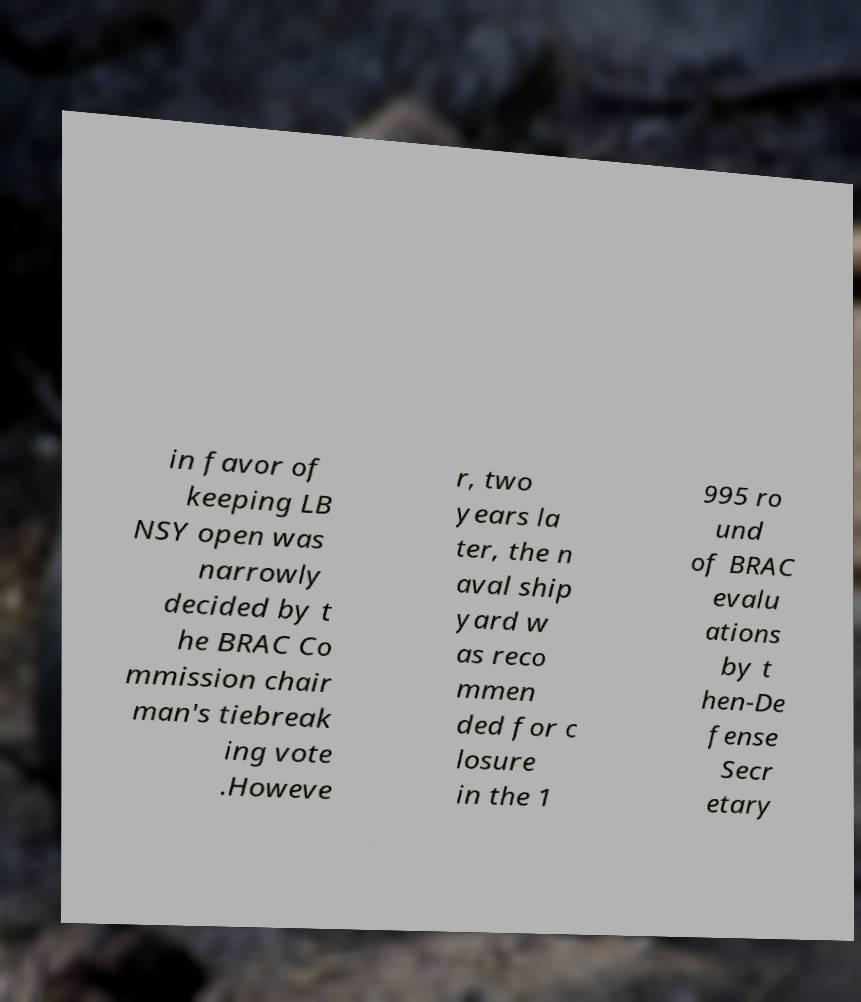What messages or text are displayed in this image? I need them in a readable, typed format. in favor of keeping LB NSY open was narrowly decided by t he BRAC Co mmission chair man's tiebreak ing vote .Howeve r, two years la ter, the n aval ship yard w as reco mmen ded for c losure in the 1 995 ro und of BRAC evalu ations by t hen-De fense Secr etary 